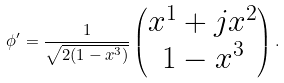Convert formula to latex. <formula><loc_0><loc_0><loc_500><loc_500>\phi ^ { \prime } = \frac { 1 } { \sqrt { 2 ( 1 - x ^ { 3 } ) } } \begin{pmatrix} x ^ { 1 } + j x ^ { 2 } \\ 1 - x ^ { 3 } \end{pmatrix} .</formula> 